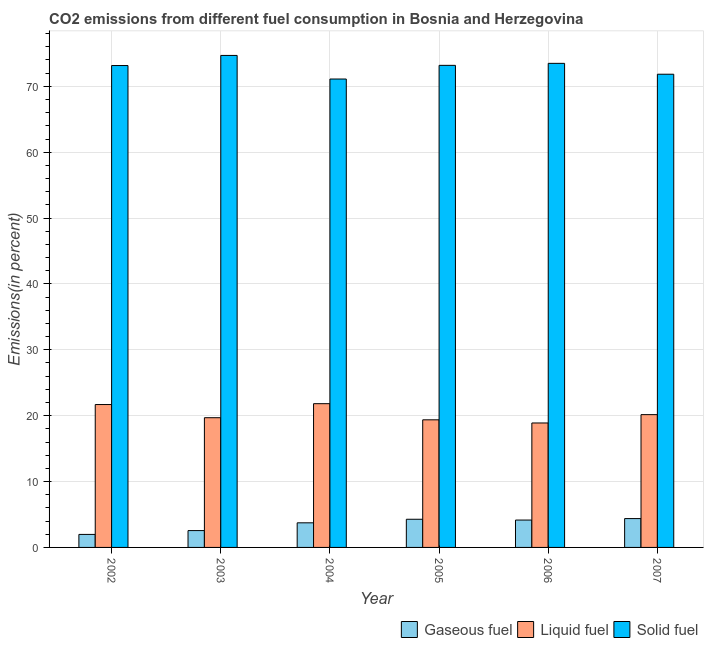Are the number of bars per tick equal to the number of legend labels?
Your response must be concise. Yes. How many bars are there on the 2nd tick from the right?
Your answer should be very brief. 3. What is the label of the 3rd group of bars from the left?
Offer a very short reply. 2004. In how many cases, is the number of bars for a given year not equal to the number of legend labels?
Ensure brevity in your answer.  0. What is the percentage of gaseous fuel emission in 2005?
Keep it short and to the point. 4.28. Across all years, what is the maximum percentage of gaseous fuel emission?
Provide a short and direct response. 4.38. Across all years, what is the minimum percentage of solid fuel emission?
Your response must be concise. 71.11. What is the total percentage of solid fuel emission in the graph?
Provide a short and direct response. 437.46. What is the difference between the percentage of gaseous fuel emission in 2003 and that in 2004?
Keep it short and to the point. -1.18. What is the difference between the percentage of gaseous fuel emission in 2007 and the percentage of liquid fuel emission in 2006?
Offer a terse response. 0.22. What is the average percentage of gaseous fuel emission per year?
Your response must be concise. 3.51. What is the ratio of the percentage of solid fuel emission in 2002 to that in 2005?
Your answer should be compact. 1. What is the difference between the highest and the second highest percentage of solid fuel emission?
Your response must be concise. 1.2. What is the difference between the highest and the lowest percentage of liquid fuel emission?
Keep it short and to the point. 2.93. In how many years, is the percentage of solid fuel emission greater than the average percentage of solid fuel emission taken over all years?
Make the answer very short. 4. Is the sum of the percentage of solid fuel emission in 2004 and 2006 greater than the maximum percentage of liquid fuel emission across all years?
Offer a terse response. Yes. What does the 3rd bar from the left in 2005 represents?
Make the answer very short. Solid fuel. What does the 2nd bar from the right in 2003 represents?
Offer a very short reply. Liquid fuel. Are all the bars in the graph horizontal?
Ensure brevity in your answer.  No. How many years are there in the graph?
Your answer should be compact. 6. What is the difference between two consecutive major ticks on the Y-axis?
Offer a very short reply. 10. Does the graph contain grids?
Provide a short and direct response. Yes. Where does the legend appear in the graph?
Give a very brief answer. Bottom right. How many legend labels are there?
Your answer should be compact. 3. How are the legend labels stacked?
Provide a short and direct response. Horizontal. What is the title of the graph?
Offer a very short reply. CO2 emissions from different fuel consumption in Bosnia and Herzegovina. What is the label or title of the Y-axis?
Ensure brevity in your answer.  Emissions(in percent). What is the Emissions(in percent) in Gaseous fuel in 2002?
Give a very brief answer. 1.97. What is the Emissions(in percent) of Liquid fuel in 2002?
Your answer should be very brief. 21.69. What is the Emissions(in percent) of Solid fuel in 2002?
Ensure brevity in your answer.  73.15. What is the Emissions(in percent) in Gaseous fuel in 2003?
Make the answer very short. 2.56. What is the Emissions(in percent) of Liquid fuel in 2003?
Give a very brief answer. 19.69. What is the Emissions(in percent) in Solid fuel in 2003?
Your response must be concise. 74.69. What is the Emissions(in percent) in Gaseous fuel in 2004?
Provide a succinct answer. 3.74. What is the Emissions(in percent) in Liquid fuel in 2004?
Give a very brief answer. 21.82. What is the Emissions(in percent) in Solid fuel in 2004?
Your answer should be compact. 71.11. What is the Emissions(in percent) in Gaseous fuel in 2005?
Keep it short and to the point. 4.28. What is the Emissions(in percent) of Liquid fuel in 2005?
Provide a short and direct response. 19.37. What is the Emissions(in percent) in Solid fuel in 2005?
Offer a terse response. 73.18. What is the Emissions(in percent) of Gaseous fuel in 2006?
Your answer should be very brief. 4.15. What is the Emissions(in percent) of Liquid fuel in 2006?
Your response must be concise. 18.89. What is the Emissions(in percent) of Solid fuel in 2006?
Ensure brevity in your answer.  73.49. What is the Emissions(in percent) of Gaseous fuel in 2007?
Ensure brevity in your answer.  4.38. What is the Emissions(in percent) in Liquid fuel in 2007?
Keep it short and to the point. 20.16. What is the Emissions(in percent) in Solid fuel in 2007?
Your answer should be very brief. 71.84. Across all years, what is the maximum Emissions(in percent) in Gaseous fuel?
Make the answer very short. 4.38. Across all years, what is the maximum Emissions(in percent) in Liquid fuel?
Give a very brief answer. 21.82. Across all years, what is the maximum Emissions(in percent) of Solid fuel?
Your answer should be compact. 74.69. Across all years, what is the minimum Emissions(in percent) of Gaseous fuel?
Ensure brevity in your answer.  1.97. Across all years, what is the minimum Emissions(in percent) in Liquid fuel?
Make the answer very short. 18.89. Across all years, what is the minimum Emissions(in percent) of Solid fuel?
Ensure brevity in your answer.  71.11. What is the total Emissions(in percent) of Gaseous fuel in the graph?
Your response must be concise. 21.07. What is the total Emissions(in percent) in Liquid fuel in the graph?
Your response must be concise. 121.63. What is the total Emissions(in percent) in Solid fuel in the graph?
Your response must be concise. 437.46. What is the difference between the Emissions(in percent) in Gaseous fuel in 2002 and that in 2003?
Your answer should be very brief. -0.58. What is the difference between the Emissions(in percent) of Liquid fuel in 2002 and that in 2003?
Give a very brief answer. 2. What is the difference between the Emissions(in percent) in Solid fuel in 2002 and that in 2003?
Provide a short and direct response. -1.54. What is the difference between the Emissions(in percent) in Gaseous fuel in 2002 and that in 2004?
Provide a short and direct response. -1.76. What is the difference between the Emissions(in percent) in Liquid fuel in 2002 and that in 2004?
Give a very brief answer. -0.13. What is the difference between the Emissions(in percent) of Solid fuel in 2002 and that in 2004?
Give a very brief answer. 2.05. What is the difference between the Emissions(in percent) in Gaseous fuel in 2002 and that in 2005?
Your answer should be very brief. -2.3. What is the difference between the Emissions(in percent) in Liquid fuel in 2002 and that in 2005?
Your answer should be compact. 2.32. What is the difference between the Emissions(in percent) of Solid fuel in 2002 and that in 2005?
Offer a terse response. -0.03. What is the difference between the Emissions(in percent) of Gaseous fuel in 2002 and that in 2006?
Offer a terse response. -2.18. What is the difference between the Emissions(in percent) of Liquid fuel in 2002 and that in 2006?
Your answer should be compact. 2.8. What is the difference between the Emissions(in percent) of Solid fuel in 2002 and that in 2006?
Offer a terse response. -0.33. What is the difference between the Emissions(in percent) of Gaseous fuel in 2002 and that in 2007?
Your answer should be very brief. -2.4. What is the difference between the Emissions(in percent) in Liquid fuel in 2002 and that in 2007?
Your answer should be very brief. 1.53. What is the difference between the Emissions(in percent) of Solid fuel in 2002 and that in 2007?
Offer a terse response. 1.32. What is the difference between the Emissions(in percent) in Gaseous fuel in 2003 and that in 2004?
Your answer should be very brief. -1.18. What is the difference between the Emissions(in percent) in Liquid fuel in 2003 and that in 2004?
Keep it short and to the point. -2.13. What is the difference between the Emissions(in percent) in Solid fuel in 2003 and that in 2004?
Provide a succinct answer. 3.58. What is the difference between the Emissions(in percent) in Gaseous fuel in 2003 and that in 2005?
Your response must be concise. -1.72. What is the difference between the Emissions(in percent) of Liquid fuel in 2003 and that in 2005?
Ensure brevity in your answer.  0.32. What is the difference between the Emissions(in percent) of Solid fuel in 2003 and that in 2005?
Provide a succinct answer. 1.51. What is the difference between the Emissions(in percent) in Gaseous fuel in 2003 and that in 2006?
Your answer should be compact. -1.6. What is the difference between the Emissions(in percent) of Liquid fuel in 2003 and that in 2006?
Ensure brevity in your answer.  0.8. What is the difference between the Emissions(in percent) of Solid fuel in 2003 and that in 2006?
Offer a very short reply. 1.2. What is the difference between the Emissions(in percent) in Gaseous fuel in 2003 and that in 2007?
Give a very brief answer. -1.82. What is the difference between the Emissions(in percent) in Liquid fuel in 2003 and that in 2007?
Provide a short and direct response. -0.47. What is the difference between the Emissions(in percent) in Solid fuel in 2003 and that in 2007?
Offer a terse response. 2.85. What is the difference between the Emissions(in percent) in Gaseous fuel in 2004 and that in 2005?
Give a very brief answer. -0.54. What is the difference between the Emissions(in percent) of Liquid fuel in 2004 and that in 2005?
Provide a short and direct response. 2.45. What is the difference between the Emissions(in percent) of Solid fuel in 2004 and that in 2005?
Keep it short and to the point. -2.08. What is the difference between the Emissions(in percent) in Gaseous fuel in 2004 and that in 2006?
Offer a terse response. -0.42. What is the difference between the Emissions(in percent) of Liquid fuel in 2004 and that in 2006?
Your answer should be compact. 2.93. What is the difference between the Emissions(in percent) of Solid fuel in 2004 and that in 2006?
Make the answer very short. -2.38. What is the difference between the Emissions(in percent) of Gaseous fuel in 2004 and that in 2007?
Offer a very short reply. -0.64. What is the difference between the Emissions(in percent) of Liquid fuel in 2004 and that in 2007?
Ensure brevity in your answer.  1.66. What is the difference between the Emissions(in percent) of Solid fuel in 2004 and that in 2007?
Your response must be concise. -0.73. What is the difference between the Emissions(in percent) in Gaseous fuel in 2005 and that in 2006?
Offer a very short reply. 0.12. What is the difference between the Emissions(in percent) of Liquid fuel in 2005 and that in 2006?
Offer a terse response. 0.48. What is the difference between the Emissions(in percent) of Solid fuel in 2005 and that in 2006?
Give a very brief answer. -0.3. What is the difference between the Emissions(in percent) in Gaseous fuel in 2005 and that in 2007?
Keep it short and to the point. -0.1. What is the difference between the Emissions(in percent) in Liquid fuel in 2005 and that in 2007?
Offer a very short reply. -0.79. What is the difference between the Emissions(in percent) in Solid fuel in 2005 and that in 2007?
Give a very brief answer. 1.35. What is the difference between the Emissions(in percent) in Gaseous fuel in 2006 and that in 2007?
Offer a very short reply. -0.22. What is the difference between the Emissions(in percent) of Liquid fuel in 2006 and that in 2007?
Make the answer very short. -1.26. What is the difference between the Emissions(in percent) of Solid fuel in 2006 and that in 2007?
Offer a very short reply. 1.65. What is the difference between the Emissions(in percent) in Gaseous fuel in 2002 and the Emissions(in percent) in Liquid fuel in 2003?
Your response must be concise. -17.72. What is the difference between the Emissions(in percent) of Gaseous fuel in 2002 and the Emissions(in percent) of Solid fuel in 2003?
Keep it short and to the point. -72.72. What is the difference between the Emissions(in percent) of Liquid fuel in 2002 and the Emissions(in percent) of Solid fuel in 2003?
Provide a succinct answer. -53. What is the difference between the Emissions(in percent) in Gaseous fuel in 2002 and the Emissions(in percent) in Liquid fuel in 2004?
Give a very brief answer. -19.85. What is the difference between the Emissions(in percent) of Gaseous fuel in 2002 and the Emissions(in percent) of Solid fuel in 2004?
Keep it short and to the point. -69.13. What is the difference between the Emissions(in percent) of Liquid fuel in 2002 and the Emissions(in percent) of Solid fuel in 2004?
Ensure brevity in your answer.  -49.41. What is the difference between the Emissions(in percent) of Gaseous fuel in 2002 and the Emissions(in percent) of Liquid fuel in 2005?
Your response must be concise. -17.4. What is the difference between the Emissions(in percent) in Gaseous fuel in 2002 and the Emissions(in percent) in Solid fuel in 2005?
Keep it short and to the point. -71.21. What is the difference between the Emissions(in percent) of Liquid fuel in 2002 and the Emissions(in percent) of Solid fuel in 2005?
Provide a succinct answer. -51.49. What is the difference between the Emissions(in percent) of Gaseous fuel in 2002 and the Emissions(in percent) of Liquid fuel in 2006?
Your answer should be very brief. -16.92. What is the difference between the Emissions(in percent) of Gaseous fuel in 2002 and the Emissions(in percent) of Solid fuel in 2006?
Offer a very short reply. -71.51. What is the difference between the Emissions(in percent) in Liquid fuel in 2002 and the Emissions(in percent) in Solid fuel in 2006?
Your answer should be compact. -51.79. What is the difference between the Emissions(in percent) in Gaseous fuel in 2002 and the Emissions(in percent) in Liquid fuel in 2007?
Give a very brief answer. -18.18. What is the difference between the Emissions(in percent) of Gaseous fuel in 2002 and the Emissions(in percent) of Solid fuel in 2007?
Your response must be concise. -69.86. What is the difference between the Emissions(in percent) of Liquid fuel in 2002 and the Emissions(in percent) of Solid fuel in 2007?
Your answer should be very brief. -50.14. What is the difference between the Emissions(in percent) in Gaseous fuel in 2003 and the Emissions(in percent) in Liquid fuel in 2004?
Your answer should be compact. -19.27. What is the difference between the Emissions(in percent) in Gaseous fuel in 2003 and the Emissions(in percent) in Solid fuel in 2004?
Give a very brief answer. -68.55. What is the difference between the Emissions(in percent) of Liquid fuel in 2003 and the Emissions(in percent) of Solid fuel in 2004?
Ensure brevity in your answer.  -51.42. What is the difference between the Emissions(in percent) in Gaseous fuel in 2003 and the Emissions(in percent) in Liquid fuel in 2005?
Your answer should be very brief. -16.81. What is the difference between the Emissions(in percent) of Gaseous fuel in 2003 and the Emissions(in percent) of Solid fuel in 2005?
Offer a very short reply. -70.63. What is the difference between the Emissions(in percent) of Liquid fuel in 2003 and the Emissions(in percent) of Solid fuel in 2005?
Provide a short and direct response. -53.49. What is the difference between the Emissions(in percent) of Gaseous fuel in 2003 and the Emissions(in percent) of Liquid fuel in 2006?
Your answer should be very brief. -16.34. What is the difference between the Emissions(in percent) of Gaseous fuel in 2003 and the Emissions(in percent) of Solid fuel in 2006?
Offer a very short reply. -70.93. What is the difference between the Emissions(in percent) in Liquid fuel in 2003 and the Emissions(in percent) in Solid fuel in 2006?
Your answer should be compact. -53.8. What is the difference between the Emissions(in percent) of Gaseous fuel in 2003 and the Emissions(in percent) of Liquid fuel in 2007?
Provide a short and direct response. -17.6. What is the difference between the Emissions(in percent) of Gaseous fuel in 2003 and the Emissions(in percent) of Solid fuel in 2007?
Offer a terse response. -69.28. What is the difference between the Emissions(in percent) of Liquid fuel in 2003 and the Emissions(in percent) of Solid fuel in 2007?
Keep it short and to the point. -52.15. What is the difference between the Emissions(in percent) of Gaseous fuel in 2004 and the Emissions(in percent) of Liquid fuel in 2005?
Offer a terse response. -15.64. What is the difference between the Emissions(in percent) in Gaseous fuel in 2004 and the Emissions(in percent) in Solid fuel in 2005?
Ensure brevity in your answer.  -69.45. What is the difference between the Emissions(in percent) of Liquid fuel in 2004 and the Emissions(in percent) of Solid fuel in 2005?
Make the answer very short. -51.36. What is the difference between the Emissions(in percent) of Gaseous fuel in 2004 and the Emissions(in percent) of Liquid fuel in 2006?
Your answer should be compact. -15.16. What is the difference between the Emissions(in percent) in Gaseous fuel in 2004 and the Emissions(in percent) in Solid fuel in 2006?
Your answer should be very brief. -69.75. What is the difference between the Emissions(in percent) in Liquid fuel in 2004 and the Emissions(in percent) in Solid fuel in 2006?
Your response must be concise. -51.66. What is the difference between the Emissions(in percent) of Gaseous fuel in 2004 and the Emissions(in percent) of Liquid fuel in 2007?
Your response must be concise. -16.42. What is the difference between the Emissions(in percent) in Gaseous fuel in 2004 and the Emissions(in percent) in Solid fuel in 2007?
Your answer should be very brief. -68.1. What is the difference between the Emissions(in percent) in Liquid fuel in 2004 and the Emissions(in percent) in Solid fuel in 2007?
Offer a very short reply. -50.01. What is the difference between the Emissions(in percent) of Gaseous fuel in 2005 and the Emissions(in percent) of Liquid fuel in 2006?
Ensure brevity in your answer.  -14.62. What is the difference between the Emissions(in percent) in Gaseous fuel in 2005 and the Emissions(in percent) in Solid fuel in 2006?
Ensure brevity in your answer.  -69.21. What is the difference between the Emissions(in percent) in Liquid fuel in 2005 and the Emissions(in percent) in Solid fuel in 2006?
Keep it short and to the point. -54.12. What is the difference between the Emissions(in percent) of Gaseous fuel in 2005 and the Emissions(in percent) of Liquid fuel in 2007?
Offer a very short reply. -15.88. What is the difference between the Emissions(in percent) of Gaseous fuel in 2005 and the Emissions(in percent) of Solid fuel in 2007?
Offer a terse response. -67.56. What is the difference between the Emissions(in percent) in Liquid fuel in 2005 and the Emissions(in percent) in Solid fuel in 2007?
Ensure brevity in your answer.  -52.47. What is the difference between the Emissions(in percent) of Gaseous fuel in 2006 and the Emissions(in percent) of Liquid fuel in 2007?
Make the answer very short. -16. What is the difference between the Emissions(in percent) of Gaseous fuel in 2006 and the Emissions(in percent) of Solid fuel in 2007?
Give a very brief answer. -67.68. What is the difference between the Emissions(in percent) in Liquid fuel in 2006 and the Emissions(in percent) in Solid fuel in 2007?
Make the answer very short. -52.94. What is the average Emissions(in percent) of Gaseous fuel per year?
Your response must be concise. 3.51. What is the average Emissions(in percent) of Liquid fuel per year?
Your answer should be compact. 20.27. What is the average Emissions(in percent) of Solid fuel per year?
Give a very brief answer. 72.91. In the year 2002, what is the difference between the Emissions(in percent) in Gaseous fuel and Emissions(in percent) in Liquid fuel?
Give a very brief answer. -19.72. In the year 2002, what is the difference between the Emissions(in percent) in Gaseous fuel and Emissions(in percent) in Solid fuel?
Give a very brief answer. -71.18. In the year 2002, what is the difference between the Emissions(in percent) in Liquid fuel and Emissions(in percent) in Solid fuel?
Make the answer very short. -51.46. In the year 2003, what is the difference between the Emissions(in percent) in Gaseous fuel and Emissions(in percent) in Liquid fuel?
Provide a succinct answer. -17.13. In the year 2003, what is the difference between the Emissions(in percent) of Gaseous fuel and Emissions(in percent) of Solid fuel?
Keep it short and to the point. -72.13. In the year 2003, what is the difference between the Emissions(in percent) of Liquid fuel and Emissions(in percent) of Solid fuel?
Ensure brevity in your answer.  -55. In the year 2004, what is the difference between the Emissions(in percent) of Gaseous fuel and Emissions(in percent) of Liquid fuel?
Provide a short and direct response. -18.09. In the year 2004, what is the difference between the Emissions(in percent) in Gaseous fuel and Emissions(in percent) in Solid fuel?
Your response must be concise. -67.37. In the year 2004, what is the difference between the Emissions(in percent) of Liquid fuel and Emissions(in percent) of Solid fuel?
Give a very brief answer. -49.28. In the year 2005, what is the difference between the Emissions(in percent) in Gaseous fuel and Emissions(in percent) in Liquid fuel?
Keep it short and to the point. -15.09. In the year 2005, what is the difference between the Emissions(in percent) in Gaseous fuel and Emissions(in percent) in Solid fuel?
Keep it short and to the point. -68.91. In the year 2005, what is the difference between the Emissions(in percent) in Liquid fuel and Emissions(in percent) in Solid fuel?
Your answer should be very brief. -53.81. In the year 2006, what is the difference between the Emissions(in percent) of Gaseous fuel and Emissions(in percent) of Liquid fuel?
Keep it short and to the point. -14.74. In the year 2006, what is the difference between the Emissions(in percent) of Gaseous fuel and Emissions(in percent) of Solid fuel?
Your response must be concise. -69.33. In the year 2006, what is the difference between the Emissions(in percent) in Liquid fuel and Emissions(in percent) in Solid fuel?
Give a very brief answer. -54.59. In the year 2007, what is the difference between the Emissions(in percent) of Gaseous fuel and Emissions(in percent) of Liquid fuel?
Keep it short and to the point. -15.78. In the year 2007, what is the difference between the Emissions(in percent) of Gaseous fuel and Emissions(in percent) of Solid fuel?
Provide a succinct answer. -67.46. In the year 2007, what is the difference between the Emissions(in percent) in Liquid fuel and Emissions(in percent) in Solid fuel?
Offer a terse response. -51.68. What is the ratio of the Emissions(in percent) in Gaseous fuel in 2002 to that in 2003?
Provide a succinct answer. 0.77. What is the ratio of the Emissions(in percent) in Liquid fuel in 2002 to that in 2003?
Make the answer very short. 1.1. What is the ratio of the Emissions(in percent) in Solid fuel in 2002 to that in 2003?
Offer a terse response. 0.98. What is the ratio of the Emissions(in percent) of Gaseous fuel in 2002 to that in 2004?
Offer a terse response. 0.53. What is the ratio of the Emissions(in percent) of Solid fuel in 2002 to that in 2004?
Make the answer very short. 1.03. What is the ratio of the Emissions(in percent) in Gaseous fuel in 2002 to that in 2005?
Give a very brief answer. 0.46. What is the ratio of the Emissions(in percent) of Liquid fuel in 2002 to that in 2005?
Provide a short and direct response. 1.12. What is the ratio of the Emissions(in percent) in Solid fuel in 2002 to that in 2005?
Make the answer very short. 1. What is the ratio of the Emissions(in percent) of Gaseous fuel in 2002 to that in 2006?
Provide a succinct answer. 0.48. What is the ratio of the Emissions(in percent) in Liquid fuel in 2002 to that in 2006?
Provide a short and direct response. 1.15. What is the ratio of the Emissions(in percent) in Solid fuel in 2002 to that in 2006?
Give a very brief answer. 1. What is the ratio of the Emissions(in percent) of Gaseous fuel in 2002 to that in 2007?
Your answer should be very brief. 0.45. What is the ratio of the Emissions(in percent) in Liquid fuel in 2002 to that in 2007?
Give a very brief answer. 1.08. What is the ratio of the Emissions(in percent) of Solid fuel in 2002 to that in 2007?
Ensure brevity in your answer.  1.02. What is the ratio of the Emissions(in percent) in Gaseous fuel in 2003 to that in 2004?
Offer a very short reply. 0.68. What is the ratio of the Emissions(in percent) of Liquid fuel in 2003 to that in 2004?
Keep it short and to the point. 0.9. What is the ratio of the Emissions(in percent) of Solid fuel in 2003 to that in 2004?
Your response must be concise. 1.05. What is the ratio of the Emissions(in percent) in Gaseous fuel in 2003 to that in 2005?
Offer a terse response. 0.6. What is the ratio of the Emissions(in percent) in Liquid fuel in 2003 to that in 2005?
Your answer should be compact. 1.02. What is the ratio of the Emissions(in percent) in Solid fuel in 2003 to that in 2005?
Your answer should be very brief. 1.02. What is the ratio of the Emissions(in percent) of Gaseous fuel in 2003 to that in 2006?
Ensure brevity in your answer.  0.62. What is the ratio of the Emissions(in percent) of Liquid fuel in 2003 to that in 2006?
Offer a terse response. 1.04. What is the ratio of the Emissions(in percent) of Solid fuel in 2003 to that in 2006?
Your answer should be compact. 1.02. What is the ratio of the Emissions(in percent) in Gaseous fuel in 2003 to that in 2007?
Offer a very short reply. 0.58. What is the ratio of the Emissions(in percent) in Liquid fuel in 2003 to that in 2007?
Your answer should be very brief. 0.98. What is the ratio of the Emissions(in percent) in Solid fuel in 2003 to that in 2007?
Your response must be concise. 1.04. What is the ratio of the Emissions(in percent) of Gaseous fuel in 2004 to that in 2005?
Provide a short and direct response. 0.87. What is the ratio of the Emissions(in percent) in Liquid fuel in 2004 to that in 2005?
Keep it short and to the point. 1.13. What is the ratio of the Emissions(in percent) in Solid fuel in 2004 to that in 2005?
Your answer should be compact. 0.97. What is the ratio of the Emissions(in percent) in Gaseous fuel in 2004 to that in 2006?
Your response must be concise. 0.9. What is the ratio of the Emissions(in percent) in Liquid fuel in 2004 to that in 2006?
Give a very brief answer. 1.16. What is the ratio of the Emissions(in percent) in Solid fuel in 2004 to that in 2006?
Make the answer very short. 0.97. What is the ratio of the Emissions(in percent) in Gaseous fuel in 2004 to that in 2007?
Your response must be concise. 0.85. What is the ratio of the Emissions(in percent) of Liquid fuel in 2004 to that in 2007?
Keep it short and to the point. 1.08. What is the ratio of the Emissions(in percent) in Gaseous fuel in 2005 to that in 2006?
Provide a short and direct response. 1.03. What is the ratio of the Emissions(in percent) in Liquid fuel in 2005 to that in 2006?
Provide a short and direct response. 1.03. What is the ratio of the Emissions(in percent) of Liquid fuel in 2005 to that in 2007?
Keep it short and to the point. 0.96. What is the ratio of the Emissions(in percent) of Solid fuel in 2005 to that in 2007?
Keep it short and to the point. 1.02. What is the ratio of the Emissions(in percent) in Gaseous fuel in 2006 to that in 2007?
Your answer should be very brief. 0.95. What is the ratio of the Emissions(in percent) of Liquid fuel in 2006 to that in 2007?
Your response must be concise. 0.94. What is the difference between the highest and the second highest Emissions(in percent) of Gaseous fuel?
Provide a short and direct response. 0.1. What is the difference between the highest and the second highest Emissions(in percent) of Liquid fuel?
Keep it short and to the point. 0.13. What is the difference between the highest and the second highest Emissions(in percent) of Solid fuel?
Offer a terse response. 1.2. What is the difference between the highest and the lowest Emissions(in percent) in Gaseous fuel?
Make the answer very short. 2.4. What is the difference between the highest and the lowest Emissions(in percent) in Liquid fuel?
Make the answer very short. 2.93. What is the difference between the highest and the lowest Emissions(in percent) in Solid fuel?
Make the answer very short. 3.58. 